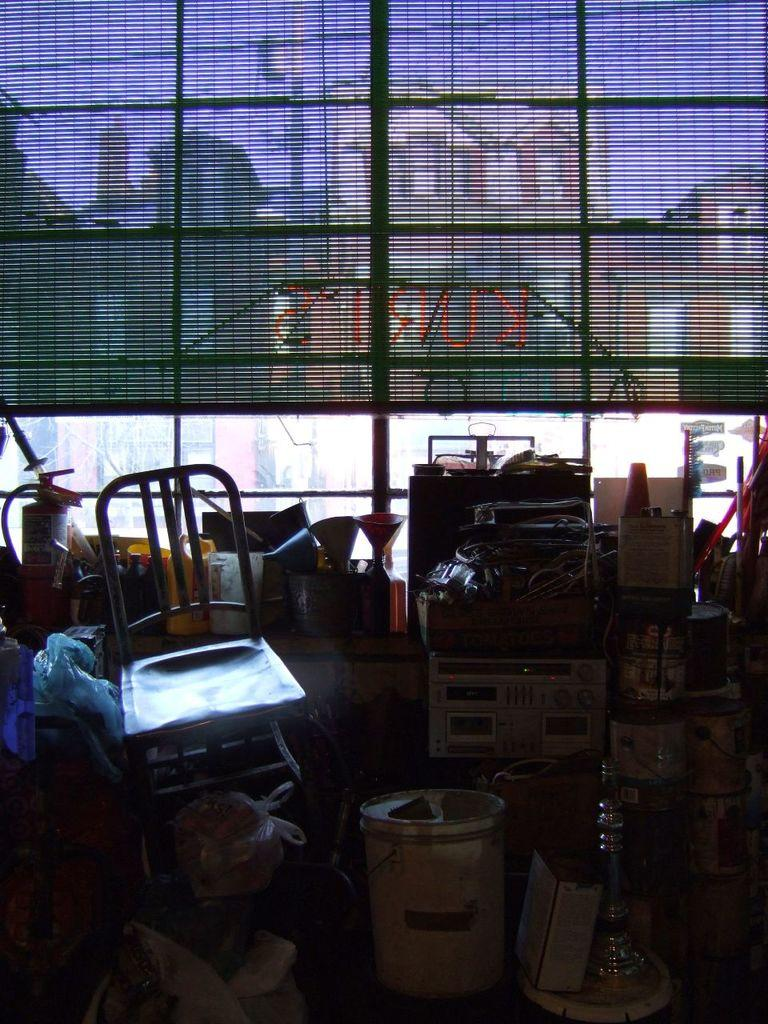What type of furniture is present in the image? There is a chair in the image. What safety device is visible in the image? There is a fire extinguisher in the image. What objects are used for holding or carrying things in the image? There are buckets in the image. What items are used to protect or cover things in the image? There are plastic covers in the image. What can be seen in the background of the image? There is a window with blinds and buildings visible in the background of the image. What is the chance of winning a prize in the image? There is no mention of a prize or any chance of winning in the image. What effect does the fire extinguisher have on the buildings in the background? The fire extinguisher is not affecting the buildings in any way; it is a safety device that is visible in the image. 